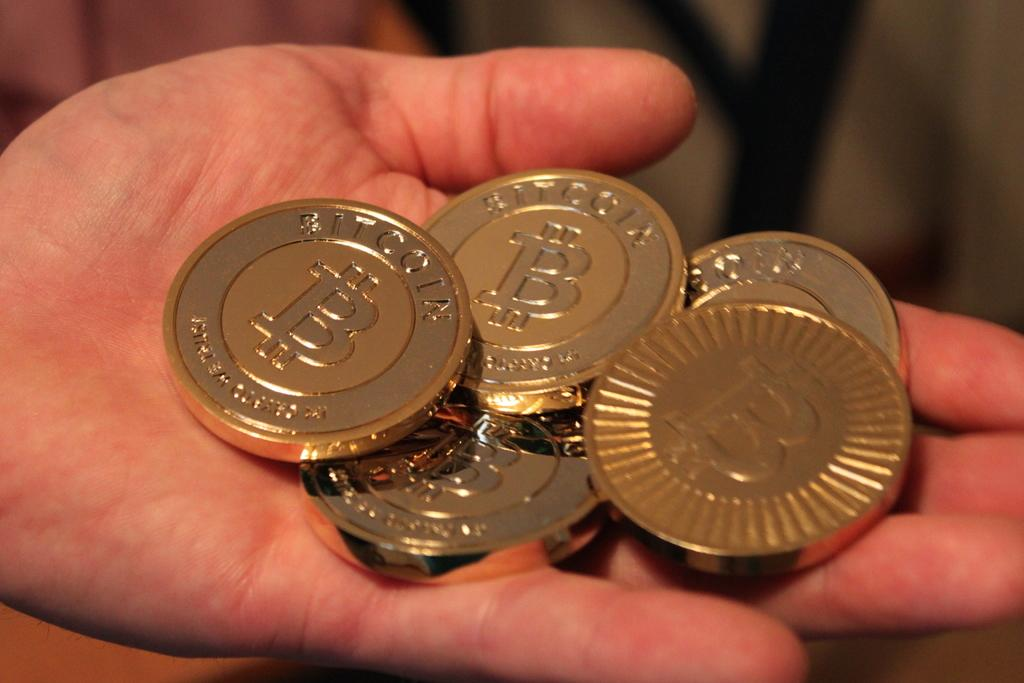What can be seen in the image that belongs to a person? There is a person's hand in the image. What is the person holding in the image? The person is holding gold-colored coins. Can you describe the background of the image? The background of the image is blurred. How many pizzas are being smashed by the robin in the image? There are no pizzas or robins present in the image. 